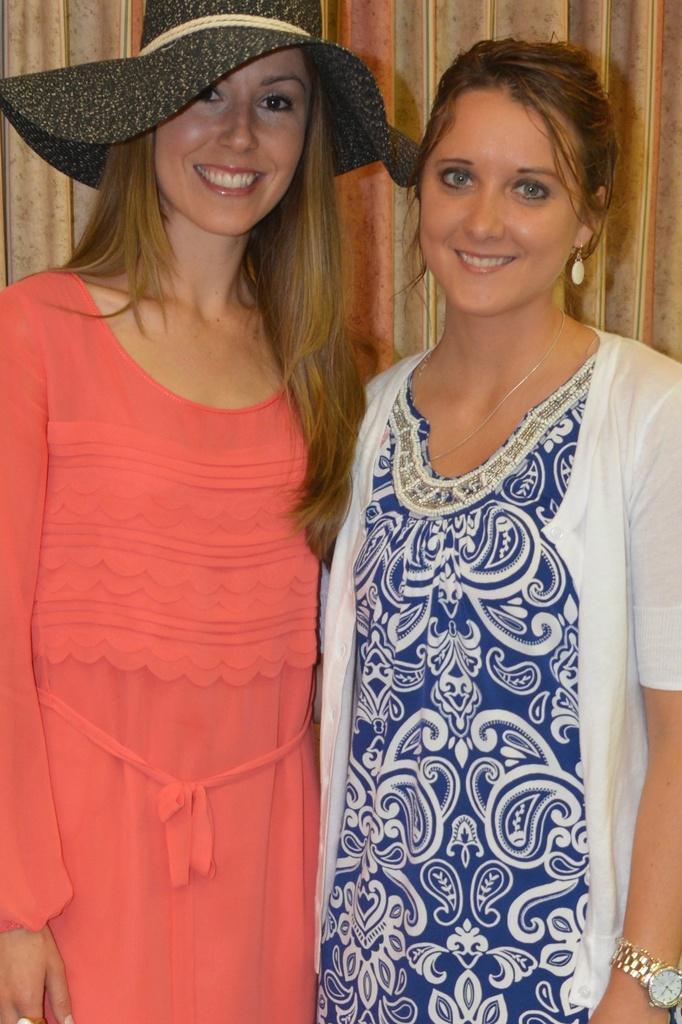Could you give a brief overview of what you see in this image? In this image I can see two people are standing and smiling. They are wearing orange,blue and white dress. Back I can see a brown background. 